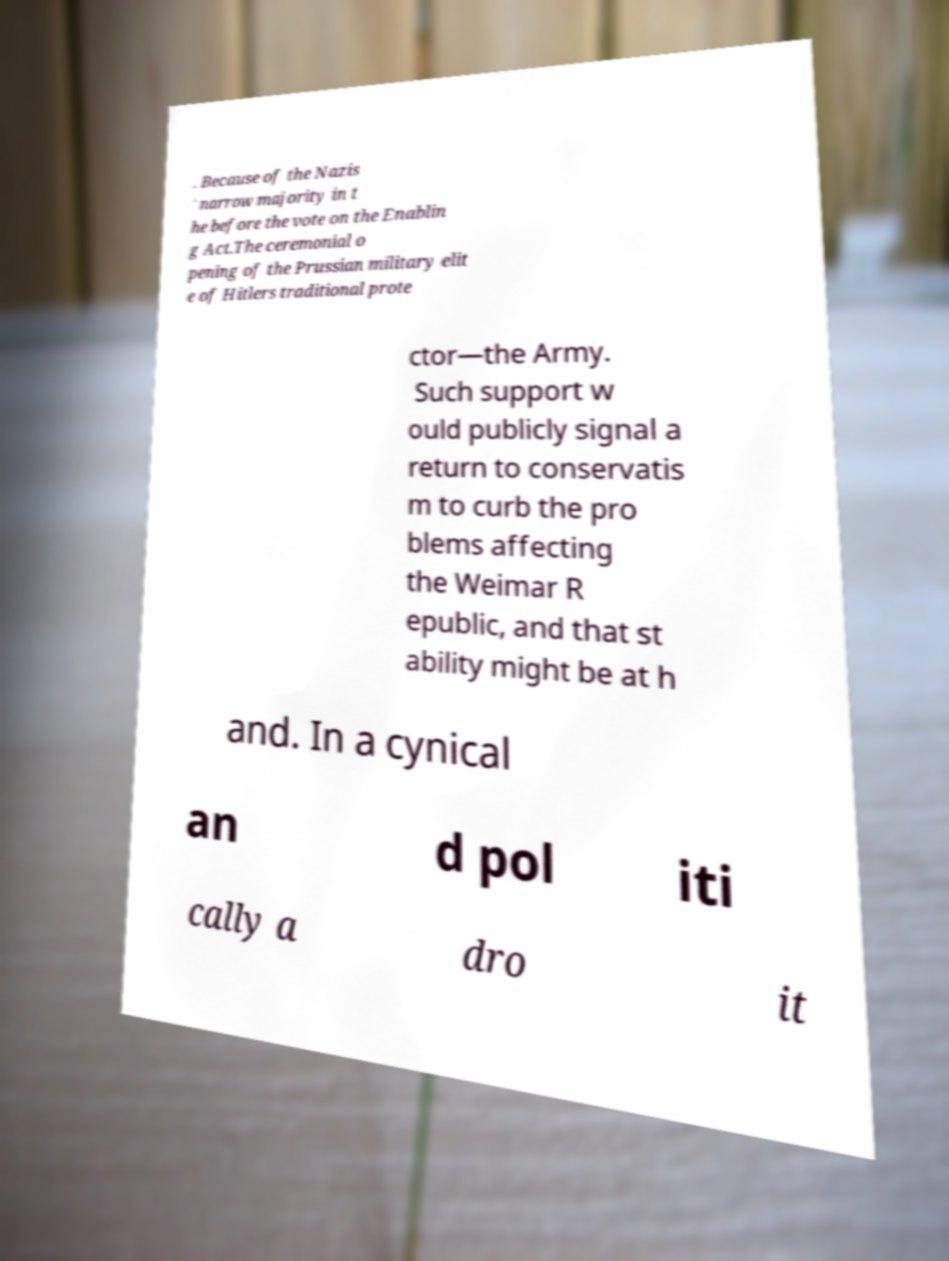Could you assist in decoding the text presented in this image and type it out clearly? . Because of the Nazis ' narrow majority in t he before the vote on the Enablin g Act.The ceremonial o pening of the Prussian military elit e of Hitlers traditional prote ctor—the Army. Such support w ould publicly signal a return to conservatis m to curb the pro blems affecting the Weimar R epublic, and that st ability might be at h and. In a cynical an d pol iti cally a dro it 